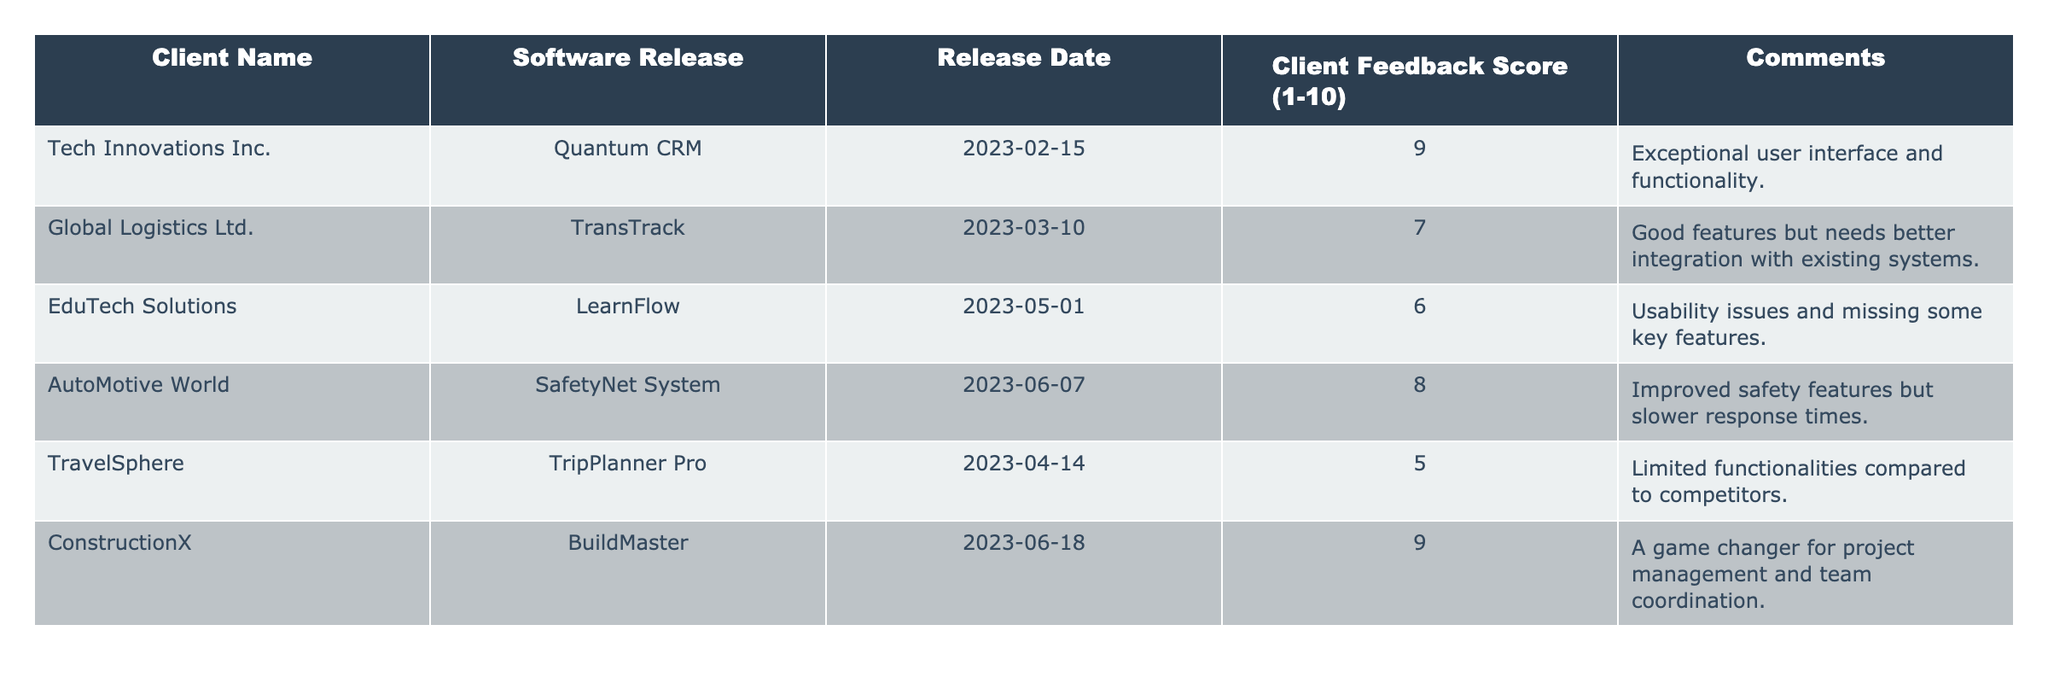What is the client feedback score for Tech Innovations Inc.? According to the table, Tech Innovations Inc. received a feedback score of 9 for their software release, Quantum CRM.
Answer: 9 What comments did Global Logistics Ltd. provide for the TransTrack software release? The comments from Global Logistics Ltd. state that the software has good features but needs better integration with existing systems.
Answer: Good features but needs better integration with existing systems How many software releases received a feedback score of 8 or higher? Two releases received a score of 8 or higher: Quantum CRM (9) and BuildMaster (9).
Answer: 2 What is the average client feedback score from the table? To find the average, add the scores: (9 + 7 + 6 + 8 + 5 + 9) = 44. There are 6 scores, so the average is 44 divided by 6, which equals approximately 7.33.
Answer: 7.33 Did any software release receive a score of 5 or lower? Yes, the TripPlanner Pro software from TravelSphere received a score of 5.
Answer: Yes What were the two software releases with the lowest feedback scores? The two software releases with the lowest scores are LearnFlow (6) and TripPlanner Pro (5).
Answer: LearnFlow and TripPlanner Pro Which client gave the highest feedback score? Tech Innovations Inc. gave the highest feedback score of 9 for Quantum CRM.
Answer: Tech Innovations Inc What is the difference between the highest and lowest feedback scores? The highest score is 9 (from Quantum CRM and BuildMaster) and the lowest score is 5 (from TripPlanner Pro). The difference is 9 - 5 = 4.
Answer: 4 What was the comment for the SafetyNet System software release? The comment for SafetyNet System states that it has improved safety features but slower response times.
Answer: Improved safety features but slower response times Which release had a score of 6, and what was the client's feedback? The release with a score of 6 is LearnFlow, and the client's feedback points out usability issues and missing some key features.
Answer: LearnFlow, usability issues and missing key features 